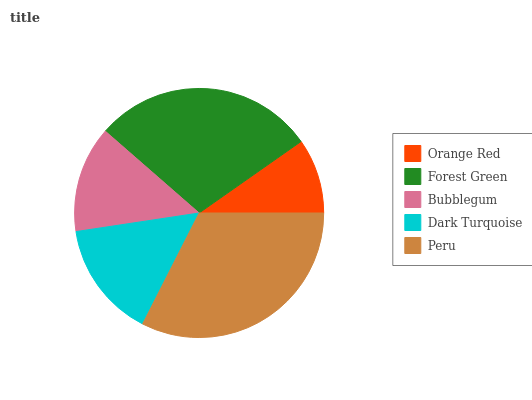Is Orange Red the minimum?
Answer yes or no. Yes. Is Peru the maximum?
Answer yes or no. Yes. Is Forest Green the minimum?
Answer yes or no. No. Is Forest Green the maximum?
Answer yes or no. No. Is Forest Green greater than Orange Red?
Answer yes or no. Yes. Is Orange Red less than Forest Green?
Answer yes or no. Yes. Is Orange Red greater than Forest Green?
Answer yes or no. No. Is Forest Green less than Orange Red?
Answer yes or no. No. Is Dark Turquoise the high median?
Answer yes or no. Yes. Is Dark Turquoise the low median?
Answer yes or no. Yes. Is Orange Red the high median?
Answer yes or no. No. Is Bubblegum the low median?
Answer yes or no. No. 